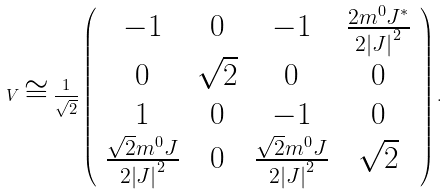<formula> <loc_0><loc_0><loc_500><loc_500>V \cong \frac { 1 } { \sqrt { 2 } } \left ( \begin{array} { c c c c } - 1 & 0 & - 1 & \frac { 2 m ^ { 0 } J ^ { \ast } } { 2 \left | J \right | ^ { 2 } } \\ 0 & \sqrt { 2 } & 0 & 0 \\ 1 & 0 & - 1 & 0 \\ \frac { \sqrt { 2 } m ^ { 0 } J } { 2 \left | J \right | ^ { 2 } } & 0 & \frac { \sqrt { 2 } m ^ { 0 } J } { 2 \left | J \right | ^ { 2 } } & \sqrt { 2 } \end{array} \right ) .</formula> 